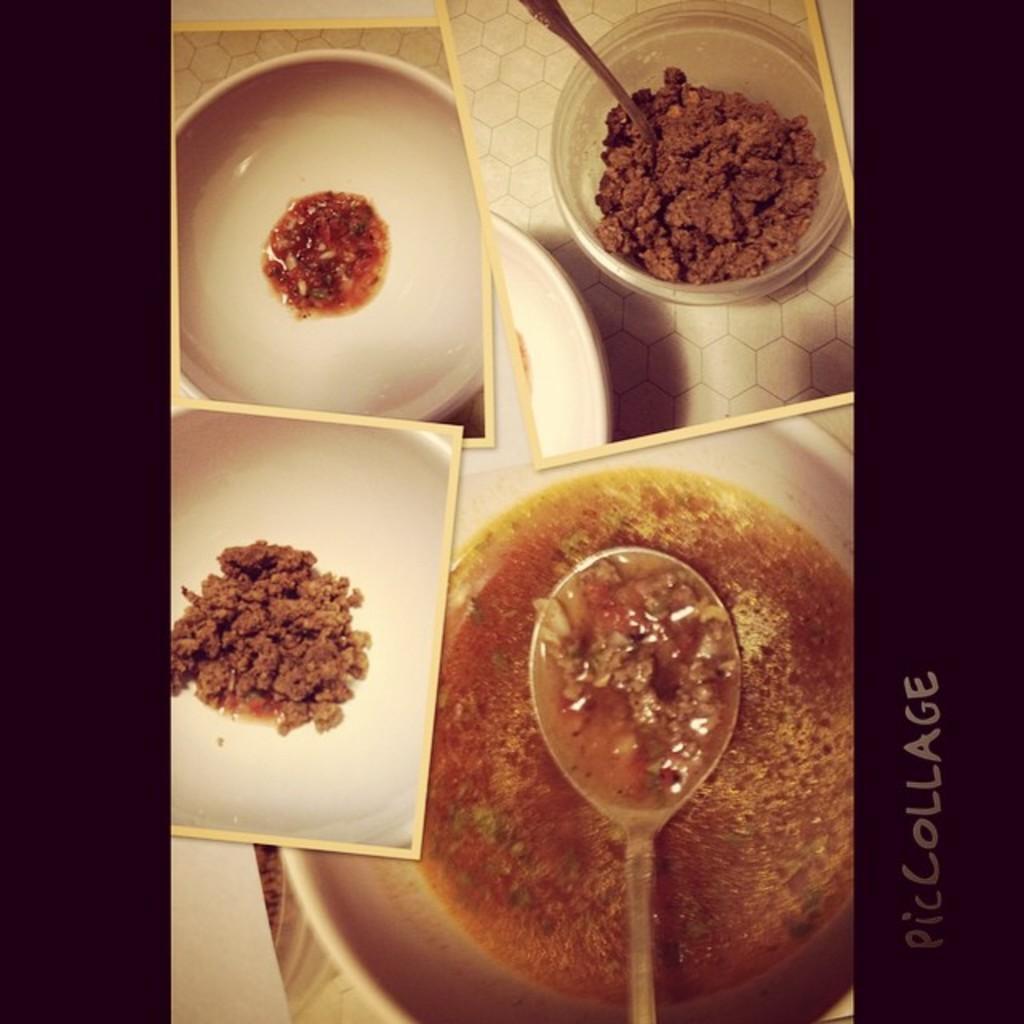How would you summarize this image in a sentence or two? In this image, we can see a bowl, inside a bowl, we can see some liquid food and a spoon. On the left side of the image, we can see a photo frame. In that image, we can see some food item. On the left top, we can see a photo frame of a bowl. In that bowl, we can see some food item. On the right side, we can see another frame. In that image, we can see some food item. 